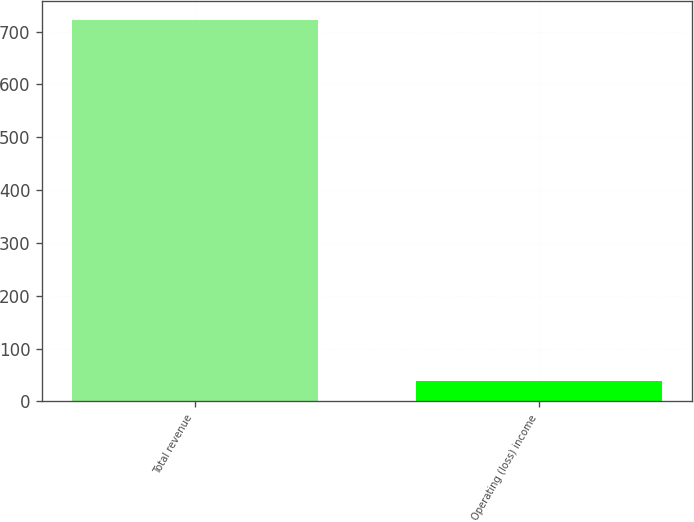<chart> <loc_0><loc_0><loc_500><loc_500><bar_chart><fcel>Total revenue<fcel>Operating (loss) income<nl><fcel>722<fcel>39<nl></chart> 